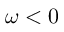Convert formula to latex. <formula><loc_0><loc_0><loc_500><loc_500>\omega < 0</formula> 